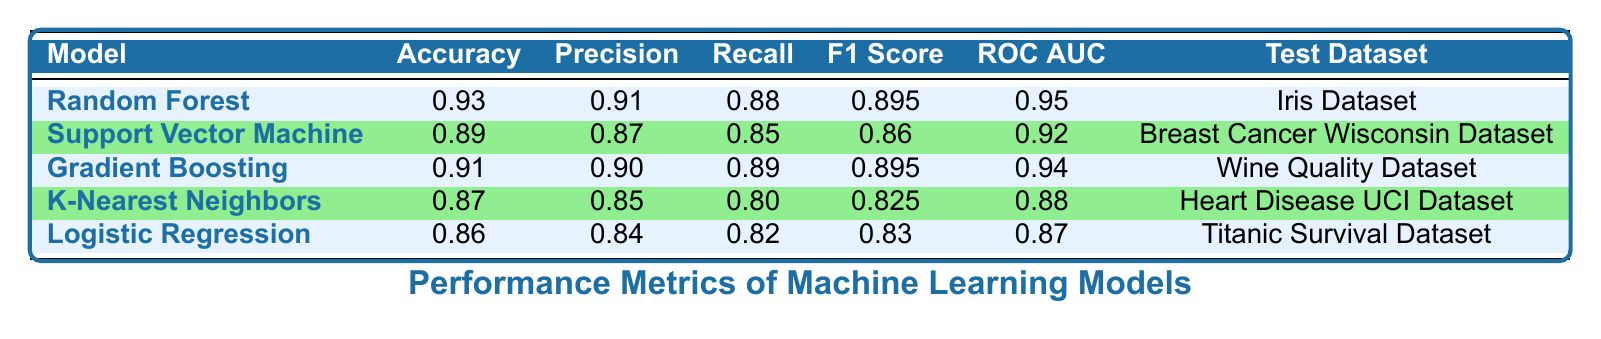What is the accuracy of the Random Forest model? The table states that the accuracy of the Random Forest model is 0.93.
Answer: 0.93 Which model has the highest ROC AUC score? The Random Forest model has the highest ROC AUC score of 0.95 when comparing the scores for all the models listed.
Answer: Random Forest What is the F1 score for the Logistic Regression model? According to the table, the F1 score for the Logistic Regression model is 0.83.
Answer: 0.83 Is the precision of K-Nearest Neighbors greater than the precision of Logistic Regression? The precision of K-Nearest Neighbors is 0.85, while the precision of Logistic Regression is 0.84. Since 0.85 > 0.84, the statement is true.
Answer: Yes What is the average accuracy of all models listed? The accuracies of the models are 0.93, 0.89, 0.91, 0.87, and 0.86. Summing these gives 4.46. Dividing by the number of models (5) gives an average accuracy of 0.892.
Answer: 0.892 Which model has the lowest recall score? The K-Nearest Neighbors model has the lowest recall score of 0.80 compared to the recall scores of the other models listed.
Answer: K-Nearest Neighbors Is there a model with both precision and recall scores above 0.90? The Random Forest and Gradient Boosting models both have precision and recall scores above 0.90 (precision 0.91 and 0.90, recall 0.88 and 0.89 respectively), confirming that the statement is true.
Answer: Yes What is the difference in F1 scores between Support Vector Machine and Gradient Boosting? The F1 score for Support Vector Machine is 0.86 and for Gradient Boosting it is 0.895. Calculating the difference: 0.895 - 0.86 gives 0.035.
Answer: 0.035 Which model has a better recall score: Support Vector Machine or Logistic Regression? The recall score for Support Vector Machine is 0.85, while for Logistic Regression it is 0.82. Since 0.85 > 0.82, Support Vector Machine has a better recall score.
Answer: Support Vector Machine 